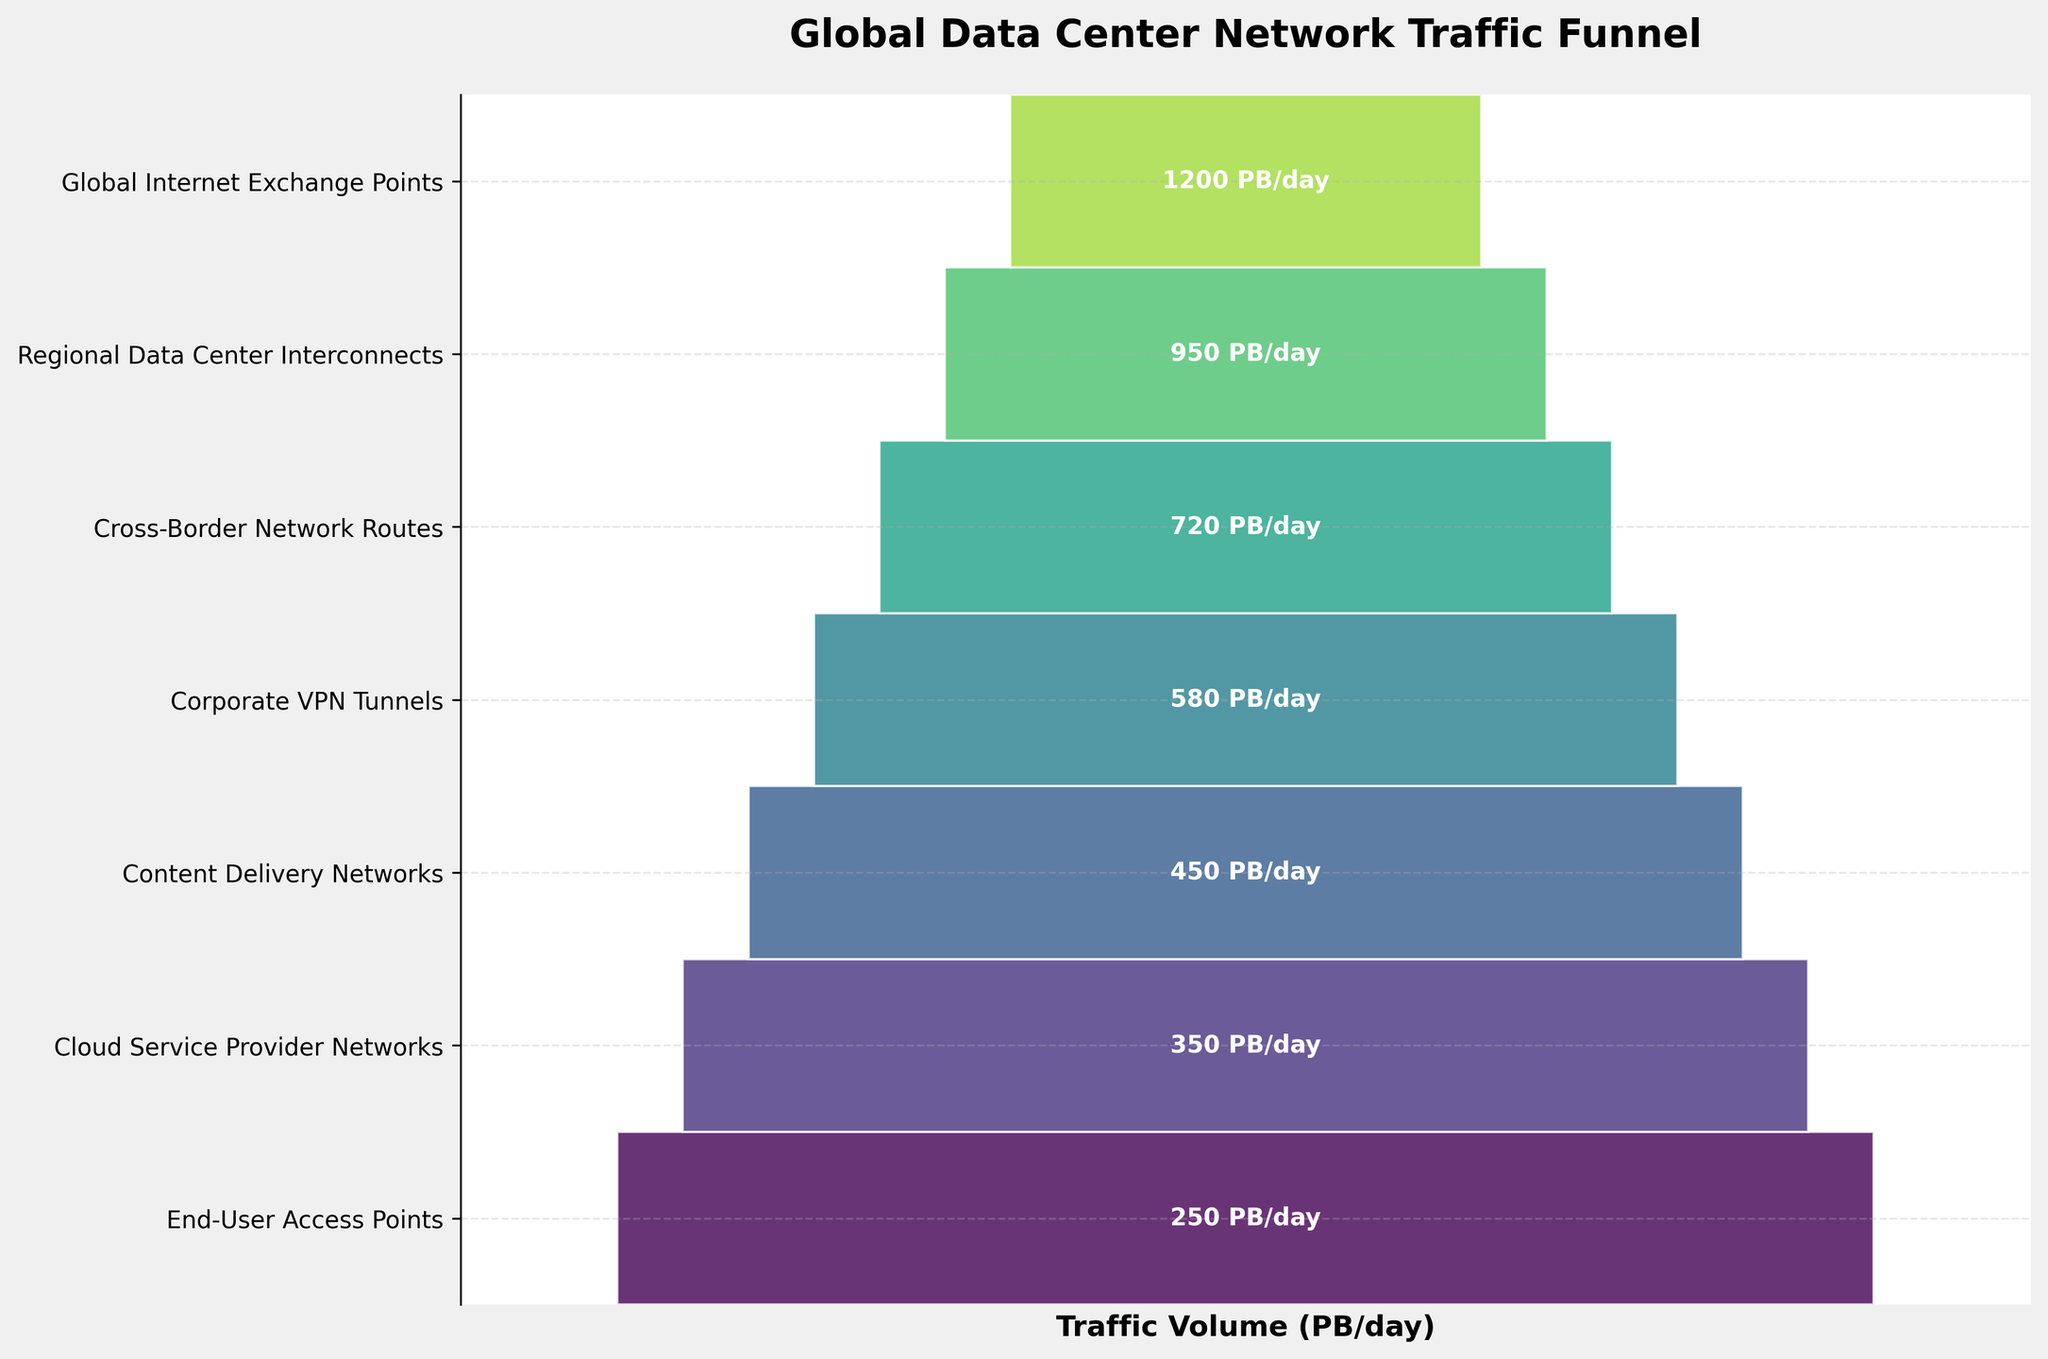How many stages are there in the funnel chart? Count the number of stages listed on the y-axis. There are 7 stages listed on the y-axis.
Answer: 7 What is the total traffic volume at the initial stage of the funnel? The initial stage is "Global Internet Exchange Points," which shows a traffic volume of 1200 PB/day.
Answer: 1200 PB/day By how much does the traffic volume decrease from "Global Internet Exchange Points" to "Regional Data Center Interconnects"? Subtract the traffic volume of "Regional Data Center Interconnects" (950 PB/day) from "Global Internet Exchange Points" (1200 PB/day). 1200 - 950 = 250 PB/day.
Answer: 250 PB/day What is the difference in traffic volume between "Corporate VPN Tunnels" and "Content Delivery Networks"? Subtract the traffic volume of "Cloud Service Provider Networks" (450 PB/day) from "Corporate VPN Tunnels" (580 PB/day). 580 - 450 = 130 PB/day.
Answer: 130 PB/day Which stage in the funnel has the lowest traffic volume, and what is that volume? The lowest traffic volume stage is "End-User Access Points" with a volume of 250 PB/day.
Answer: End-User Access Points, 250 PB/day How much more traffic volume does "Cross-Border Network Routes" handle compared to "End-User Access Points"? Subtract the traffic volume of "End-User Access Points" (250 PB/day) from "Cross-Border Network Routes" (720 PB/day). 720 - 250 = 470 PB/day.
Answer: 470 PB/day What's the percentage decrease in traffic volume from "Regional Data Center Interconnects" to "Cross-Border Network Routes"? Subtract "Cross-Border Network Routes" (720 PB/day) from "Regional Data Center Interconnects" (950 PB/day), then divide by 950 PB/day and multiply by 100. ((950 - 720) / 950) * 100 = 24.21%.
Answer: 24.21% Which stage has a volume closest to half of "Global Internet Exchange Points"? Half of "Global Internet Exchange Points" is 1200 / 2 = 600 PB/day. "Corporate VPN Tunnels" has a volume of 580 PB/day, which is closest to 600 PB/day.
Answer: Corporate VPN Tunnels What is the combined traffic volume of all the stages below "Cross-Border Network Routes"? Sum the traffic volumes of the stages below "Cross-Border Network Routes"—"Corporate VPN Tunnels" (580 PB/day), "Content Delivery Networks" (450 PB/day), "Cloud Service Provider Networks" (350 PB/day), and "End-User Access Points" (250 PB/day). 580 + 450 + 350 + 250 = 1630 PB/day.
Answer: 1630 PB/day 